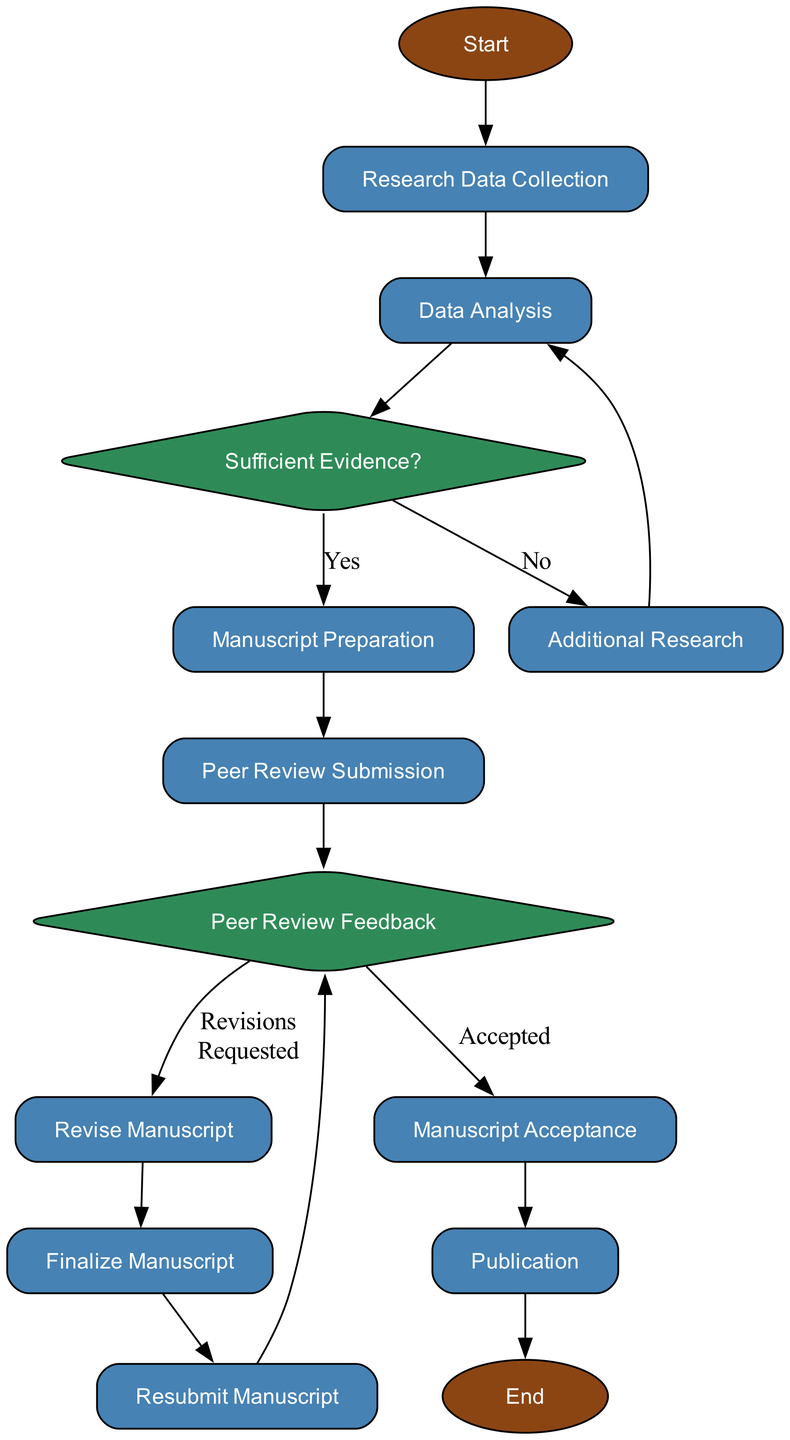What is the first step in the publishing procedure? The first node in the diagram is labeled "Start," which indicates the beginning of the publishing process.
Answer: Start How many decision nodes are present in the flowchart? There are three decision nodes in the flowchart: "Sufficient Evidence?", "Peer Review Feedback," and one more decision regarding revisions or acceptance.
Answer: 3 What follows after "Data Analysis" in the flowchart? After "Data Analysis," the flowchart leads to the decision node "Sufficient Evidence?" indicating the next step depends on the analysis results.
Answer: Sufficient Evidence? If the evidence is insufficient, what is the next process indicated? If the evidence is insufficient, indicated by "No" from the decision node, the flowchart directs to "Additional Research."
Answer: Additional Research What happens if revisions are not requested after peer review? If revisions are not requested, the flow proceeds from "Peer Review Feedback" directly to the "Manuscript Acceptance" node.
Answer: Manuscript Acceptance How many processes are there before finalizing the manuscript? There are five process nodes before "Finalize Manuscript": "Research Data Collection," "Data Analysis," "Manuscript Preparation," "Peer Review Submission," and "Revise Manuscript."
Answer: 5 What is the last step of the procedure? The last step in the flowchart is labeled "End," indicating the completion of the publishing process after "Publication."
Answer: End What is the action taken after receiving peer review feedback? The action taken after receiving peer review feedback is to "Revise Manuscript" if revisions are requested, as indicated in the flowchart.
Answer: Revise Manuscript Which node indicates the final step of the manuscript process before publication? The final process before the publication is "Finalize Manuscript," where the manuscript is prepared for publication after revisions are incorporated.
Answer: Finalize Manuscript 